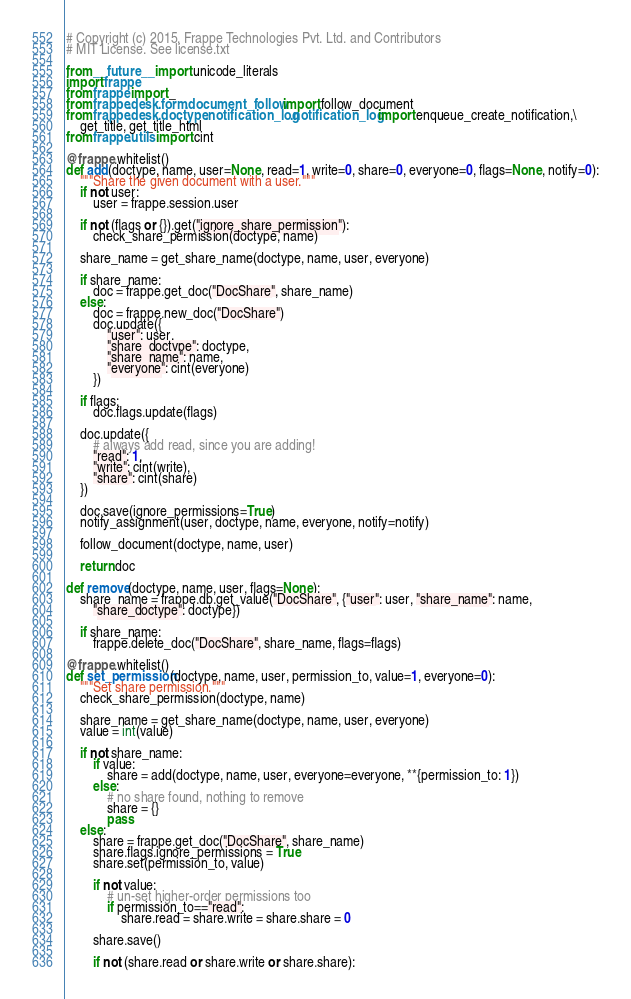<code> <loc_0><loc_0><loc_500><loc_500><_Python_># Copyright (c) 2015, Frappe Technologies Pvt. Ltd. and Contributors
# MIT License. See license.txt

from __future__ import unicode_literals
import frappe
from frappe import _
from frappe.desk.form.document_follow import follow_document
from frappe.desk.doctype.notification_log.notification_log import enqueue_create_notification,\
	get_title, get_title_html
from frappe.utils import cint

@frappe.whitelist()
def add(doctype, name, user=None, read=1, write=0, share=0, everyone=0, flags=None, notify=0):
	"""Share the given document with a user."""
	if not user:
		user = frappe.session.user

	if not (flags or {}).get("ignore_share_permission"):
		check_share_permission(doctype, name)

	share_name = get_share_name(doctype, name, user, everyone)

	if share_name:
		doc = frappe.get_doc("DocShare", share_name)
	else:
		doc = frappe.new_doc("DocShare")
		doc.update({
			"user": user,
			"share_doctype": doctype,
			"share_name": name,
			"everyone": cint(everyone)
		})

	if flags:
		doc.flags.update(flags)

	doc.update({
		# always add read, since you are adding!
		"read": 1,
		"write": cint(write),
		"share": cint(share)
	})

	doc.save(ignore_permissions=True)
	notify_assignment(user, doctype, name, everyone, notify=notify)

	follow_document(doctype, name, user)

	return doc

def remove(doctype, name, user, flags=None):
	share_name = frappe.db.get_value("DocShare", {"user": user, "share_name": name,
		"share_doctype": doctype})

	if share_name:
		frappe.delete_doc("DocShare", share_name, flags=flags)

@frappe.whitelist()
def set_permission(doctype, name, user, permission_to, value=1, everyone=0):
	"""Set share permission."""
	check_share_permission(doctype, name)

	share_name = get_share_name(doctype, name, user, everyone)
	value = int(value)

	if not share_name:
		if value:
			share = add(doctype, name, user, everyone=everyone, **{permission_to: 1})
		else:
			# no share found, nothing to remove
			share = {}
			pass
	else:
		share = frappe.get_doc("DocShare", share_name)
		share.flags.ignore_permissions = True
		share.set(permission_to, value)

		if not value:
			# un-set higher-order permissions too
			if permission_to=="read":
				share.read = share.write = share.share = 0

		share.save()

		if not (share.read or share.write or share.share):</code> 